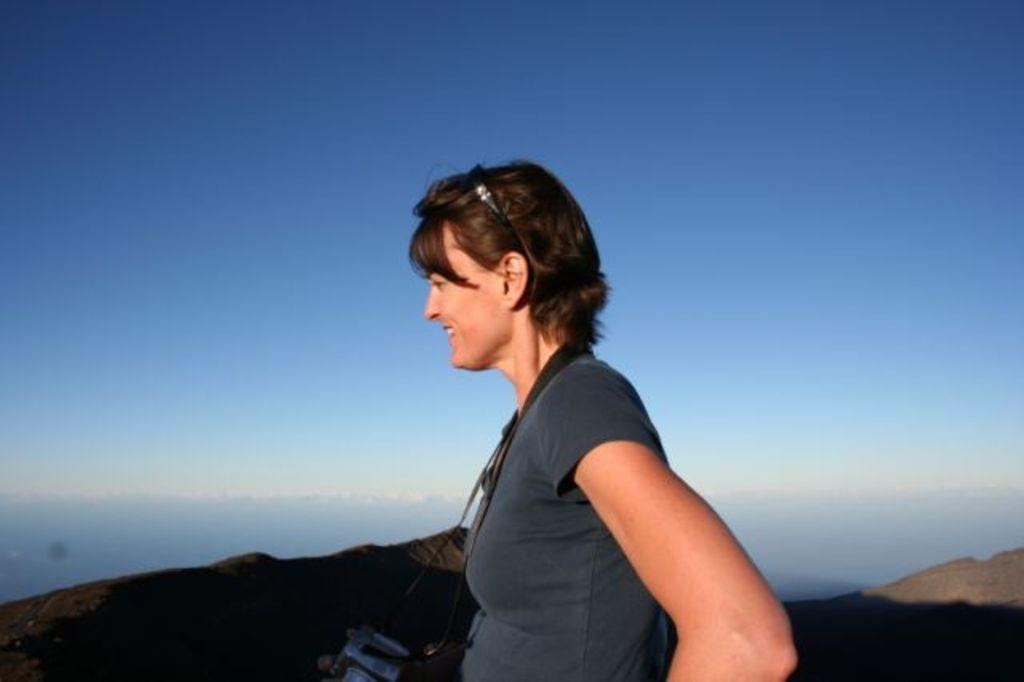What is the person in the image doing? The person is standing in the image and holding a camera. What can be seen in the distance in the image? There are hills visible in the image. What is visible in the background of the image? The sky is visible in the background of the image. What type of can is the person holding in the image? There is no can present in the image; the person is holding a camera. What kind of teeth can be seen in the image? There are no teeth visible in the image, as it features a person holding a camera and a landscape with hills and sky. 